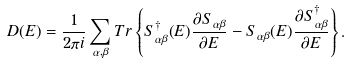<formula> <loc_0><loc_0><loc_500><loc_500>D ( E ) = \frac { 1 } { 2 \pi i } \sum _ { \alpha , \beta } T r \left \{ S _ { \alpha \beta } ^ { \dagger } ( E ) \frac { \partial S _ { \alpha \beta } } { \partial E } - S _ { \alpha \beta } ( E ) \frac { \partial S _ { \alpha \beta } ^ { \dagger } } { \partial E } \right \} .</formula> 